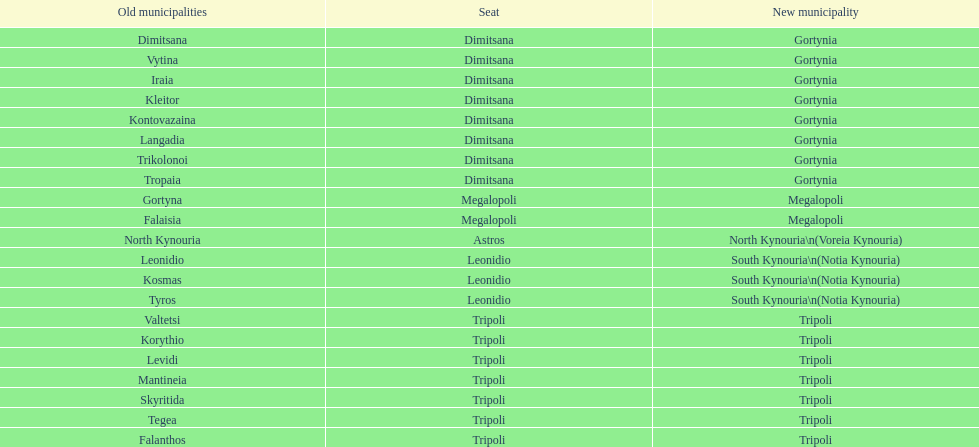Can you parse all the data within this table? {'header': ['Old municipalities', 'Seat', 'New municipality'], 'rows': [['Dimitsana', 'Dimitsana', 'Gortynia'], ['Vytina', 'Dimitsana', 'Gortynia'], ['Iraia', 'Dimitsana', 'Gortynia'], ['Kleitor', 'Dimitsana', 'Gortynia'], ['Kontovazaina', 'Dimitsana', 'Gortynia'], ['Langadia', 'Dimitsana', 'Gortynia'], ['Trikolonoi', 'Dimitsana', 'Gortynia'], ['Tropaia', 'Dimitsana', 'Gortynia'], ['Gortyna', 'Megalopoli', 'Megalopoli'], ['Falaisia', 'Megalopoli', 'Megalopoli'], ['North Kynouria', 'Astros', 'North Kynouria\\n(Voreia Kynouria)'], ['Leonidio', 'Leonidio', 'South Kynouria\\n(Notia Kynouria)'], ['Kosmas', 'Leonidio', 'South Kynouria\\n(Notia Kynouria)'], ['Tyros', 'Leonidio', 'South Kynouria\\n(Notia Kynouria)'], ['Valtetsi', 'Tripoli', 'Tripoli'], ['Korythio', 'Tripoli', 'Tripoli'], ['Levidi', 'Tripoli', 'Tripoli'], ['Mantineia', 'Tripoli', 'Tripoli'], ['Skyritida', 'Tripoli', 'Tripoli'], ['Tegea', 'Tripoli', 'Tripoli'], ['Falanthos', 'Tripoli', 'Tripoli']]} What is the new municipality of tyros? South Kynouria. 